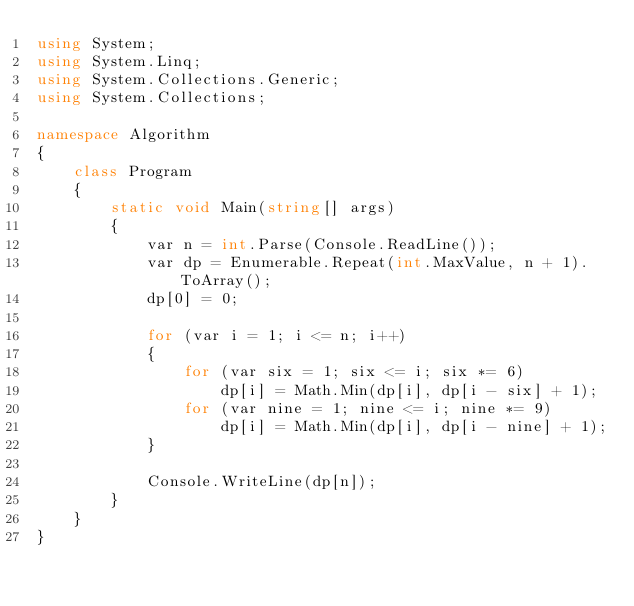Convert code to text. <code><loc_0><loc_0><loc_500><loc_500><_C#_>using System;
using System.Linq;
using System.Collections.Generic;
using System.Collections;

namespace Algorithm
{
    class Program
    {
        static void Main(string[] args)
        {
            var n = int.Parse(Console.ReadLine());
            var dp = Enumerable.Repeat(int.MaxValue, n + 1).ToArray();
            dp[0] = 0;

            for (var i = 1; i <= n; i++)
            {
                for (var six = 1; six <= i; six *= 6)
                    dp[i] = Math.Min(dp[i], dp[i - six] + 1);
                for (var nine = 1; nine <= i; nine *= 9)
                    dp[i] = Math.Min(dp[i], dp[i - nine] + 1);
            }

            Console.WriteLine(dp[n]);
        }
    }
}
</code> 